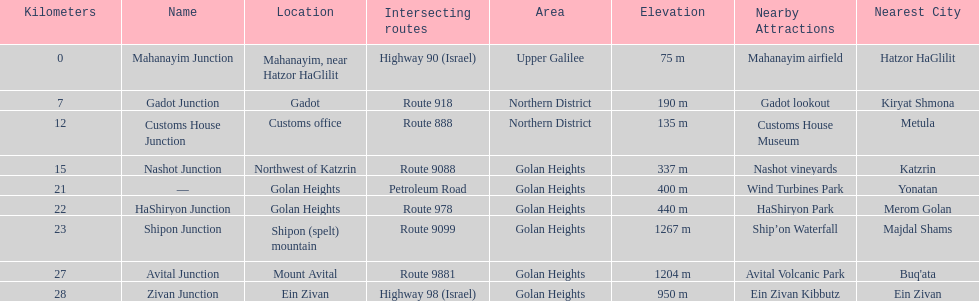Would you be able to parse every entry in this table? {'header': ['Kilometers', 'Name', 'Location', 'Intersecting routes', 'Area', 'Elevation', 'Nearby Attractions', 'Nearest City'], 'rows': [['0', 'Mahanayim Junction', 'Mahanayim, near Hatzor HaGlilit', 'Highway 90 (Israel)', 'Upper Galilee', '75 m', 'Mahanayim airfield', 'Hatzor HaGlilit'], ['7', 'Gadot Junction', 'Gadot', 'Route 918', 'Northern District', '190 m', 'Gadot lookout', 'Kiryat Shmona'], ['12', 'Customs House Junction', 'Customs office', 'Route 888', 'Northern District', '135 m', 'Customs House Museum', 'Metula'], ['15', 'Nashot Junction', 'Northwest of Katzrin', 'Route 9088', 'Golan Heights', '337 m', 'Nashot vineyards', 'Katzrin'], ['21', '—', 'Golan Heights', 'Petroleum Road', 'Golan Heights', '400 m', 'Wind Turbines Park', 'Yonatan'], ['22', 'HaShiryon Junction', 'Golan Heights', 'Route 978', 'Golan Heights', '440 m', 'HaShiryon Park', 'Merom Golan'], ['23', 'Shipon Junction', 'Shipon (spelt) mountain', 'Route 9099', 'Golan Heights', '1267 m', 'Ship’on Waterfall', 'Majdal Shams'], ['27', 'Avital Junction', 'Mount Avital', 'Route 9881', 'Golan Heights', '1204 m', 'Avital Volcanic Park', "Buq'ata"], ['28', 'Zivan Junction', 'Ein Zivan', 'Highway 98 (Israel)', 'Golan Heights', '950 m', 'Ein Zivan Kibbutz', 'Ein Zivan']]} Is nashot junction closer to shipon junction or avital junction? Shipon Junction. 